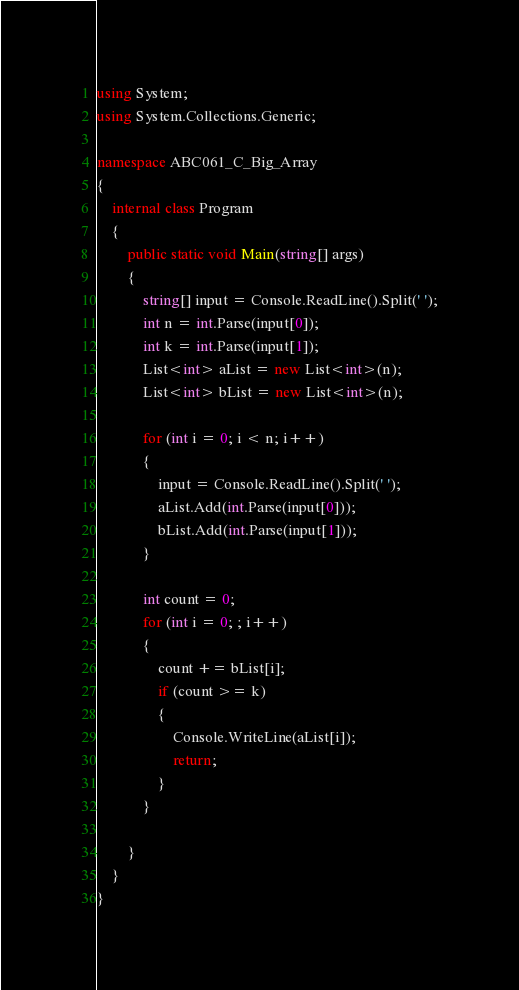Convert code to text. <code><loc_0><loc_0><loc_500><loc_500><_C#_>using System;
using System.Collections.Generic;

namespace ABC061_C_Big_Array
{
	internal class Program
	{
		public static void Main(string[] args)
		{
			string[] input = Console.ReadLine().Split(' ');
			int n = int.Parse(input[0]);
			int k = int.Parse(input[1]);
			List<int> aList = new List<int>(n);
			List<int> bList = new List<int>(n);

			for (int i = 0; i < n; i++)
			{
				input = Console.ReadLine().Split(' ');
				aList.Add(int.Parse(input[0]));
				bList.Add(int.Parse(input[1]));
			}

			int count = 0;
			for (int i = 0; ; i++)
			{
				count += bList[i];
				if (count >= k)
				{
					Console.WriteLine(aList[i]);
					return;
				}
			}
				
		}
	}
}</code> 